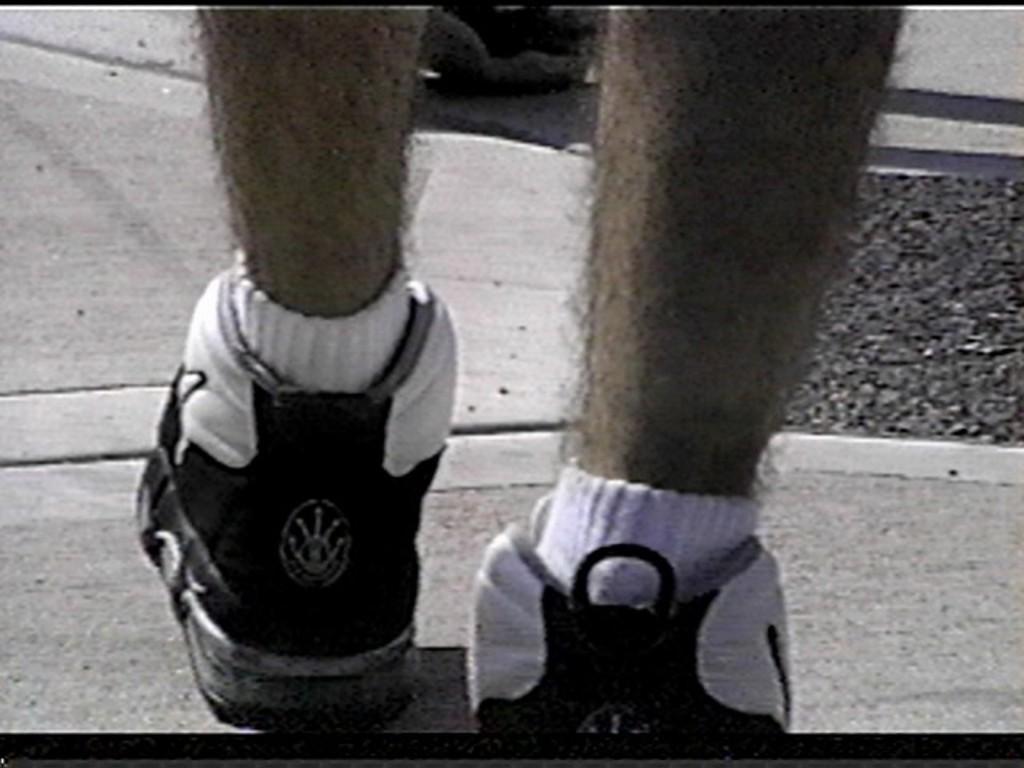Could you give a brief overview of what you see in this image? In this image we can see there are two legs with the shoes. 